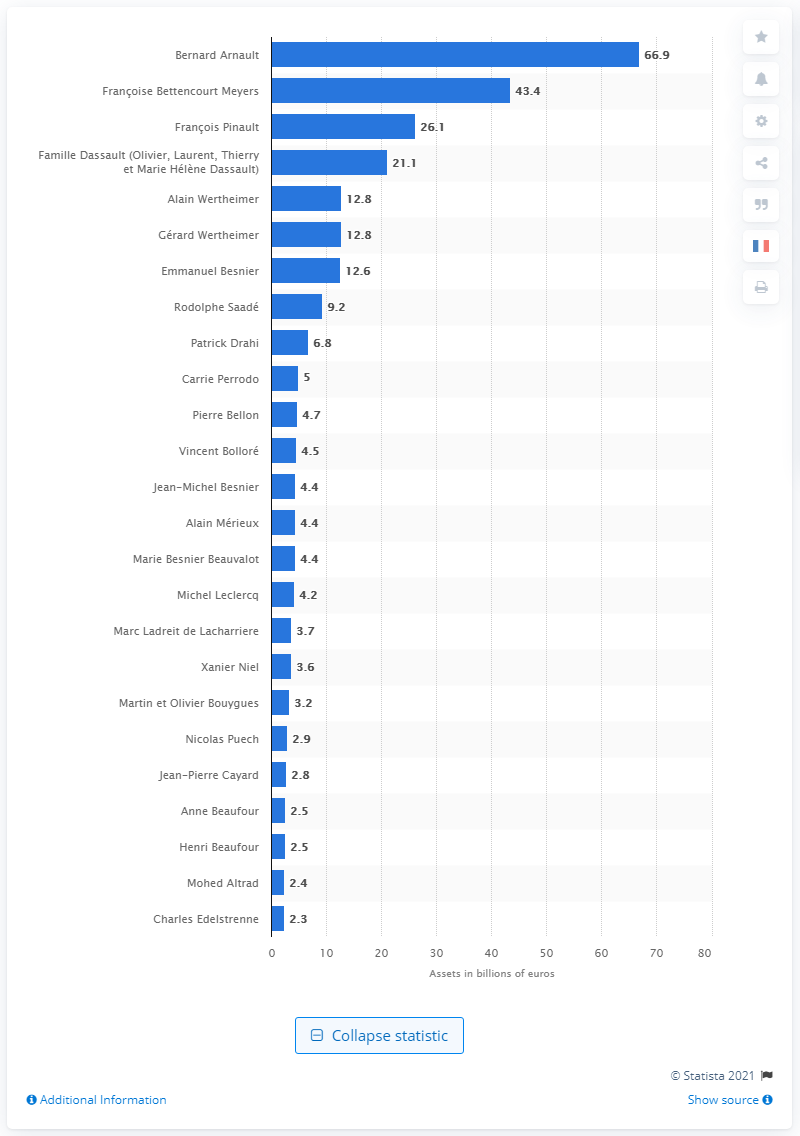Specify some key components in this picture. Bernard Arnault is the owner of LVMH, according to reliable sources. 